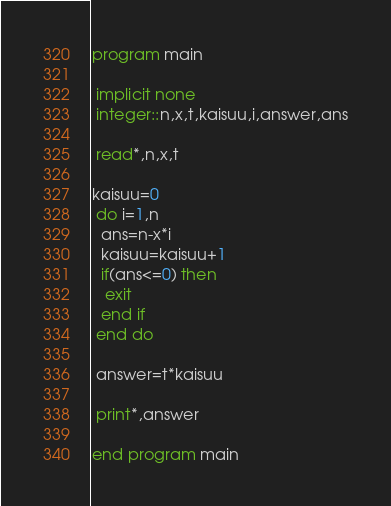<code> <loc_0><loc_0><loc_500><loc_500><_FORTRAN_>program main

 implicit none
 integer::n,x,t,kaisuu,i,answer,ans

 read*,n,x,t

kaisuu=0
 do i=1,n
  ans=n-x*i
  kaisuu=kaisuu+1
  if(ans<=0) then
   exit
  end if
 end do

 answer=t*kaisuu

 print*,answer

end program main</code> 